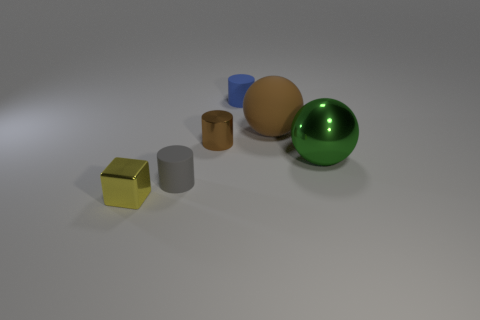Is the material of the large ball in front of the large rubber sphere the same as the small gray thing?
Keep it short and to the point. No. What is the color of the metallic object that is both on the left side of the big shiny thing and behind the gray matte cylinder?
Your answer should be compact. Brown. There is a large thing behind the big green metallic object; what number of brown things are behind it?
Your answer should be very brief. 0. What material is the other large object that is the same shape as the large brown thing?
Give a very brief answer. Metal. What is the color of the small metal cylinder?
Offer a very short reply. Brown. How many things are gray rubber cylinders or tiny blue rubber cubes?
Your answer should be very brief. 1. What shape is the metal thing in front of the big ball in front of the brown rubber sphere?
Make the answer very short. Cube. How many other things are made of the same material as the green thing?
Give a very brief answer. 2. Do the small blue cylinder and the cylinder in front of the big metal object have the same material?
Keep it short and to the point. Yes. What number of things are either spheres behind the small brown thing or metallic objects to the left of the matte ball?
Your answer should be compact. 3. 